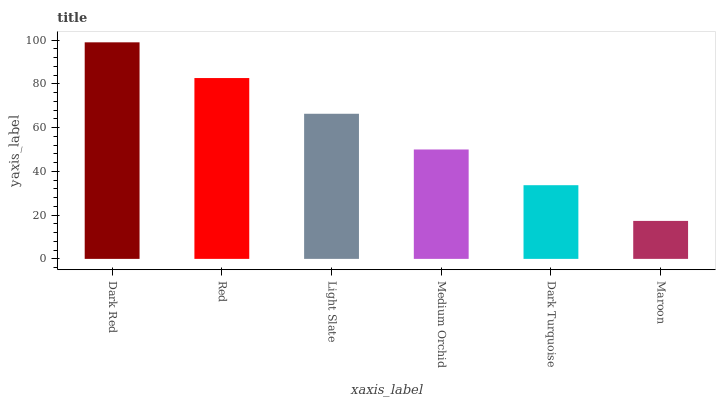Is Maroon the minimum?
Answer yes or no. Yes. Is Dark Red the maximum?
Answer yes or no. Yes. Is Red the minimum?
Answer yes or no. No. Is Red the maximum?
Answer yes or no. No. Is Dark Red greater than Red?
Answer yes or no. Yes. Is Red less than Dark Red?
Answer yes or no. Yes. Is Red greater than Dark Red?
Answer yes or no. No. Is Dark Red less than Red?
Answer yes or no. No. Is Light Slate the high median?
Answer yes or no. Yes. Is Medium Orchid the low median?
Answer yes or no. Yes. Is Medium Orchid the high median?
Answer yes or no. No. Is Dark Red the low median?
Answer yes or no. No. 